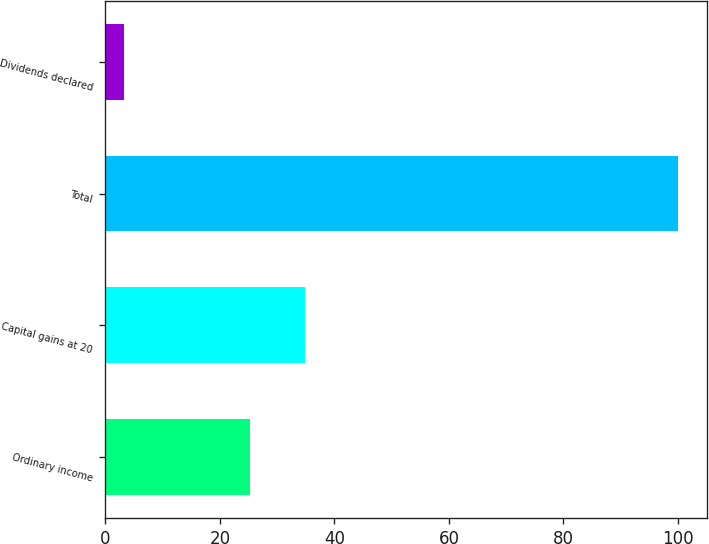Convert chart. <chart><loc_0><loc_0><loc_500><loc_500><bar_chart><fcel>Ordinary income<fcel>Capital gains at 20<fcel>Total<fcel>Dividends declared<nl><fcel>25.2<fcel>34.88<fcel>100<fcel>3.23<nl></chart> 